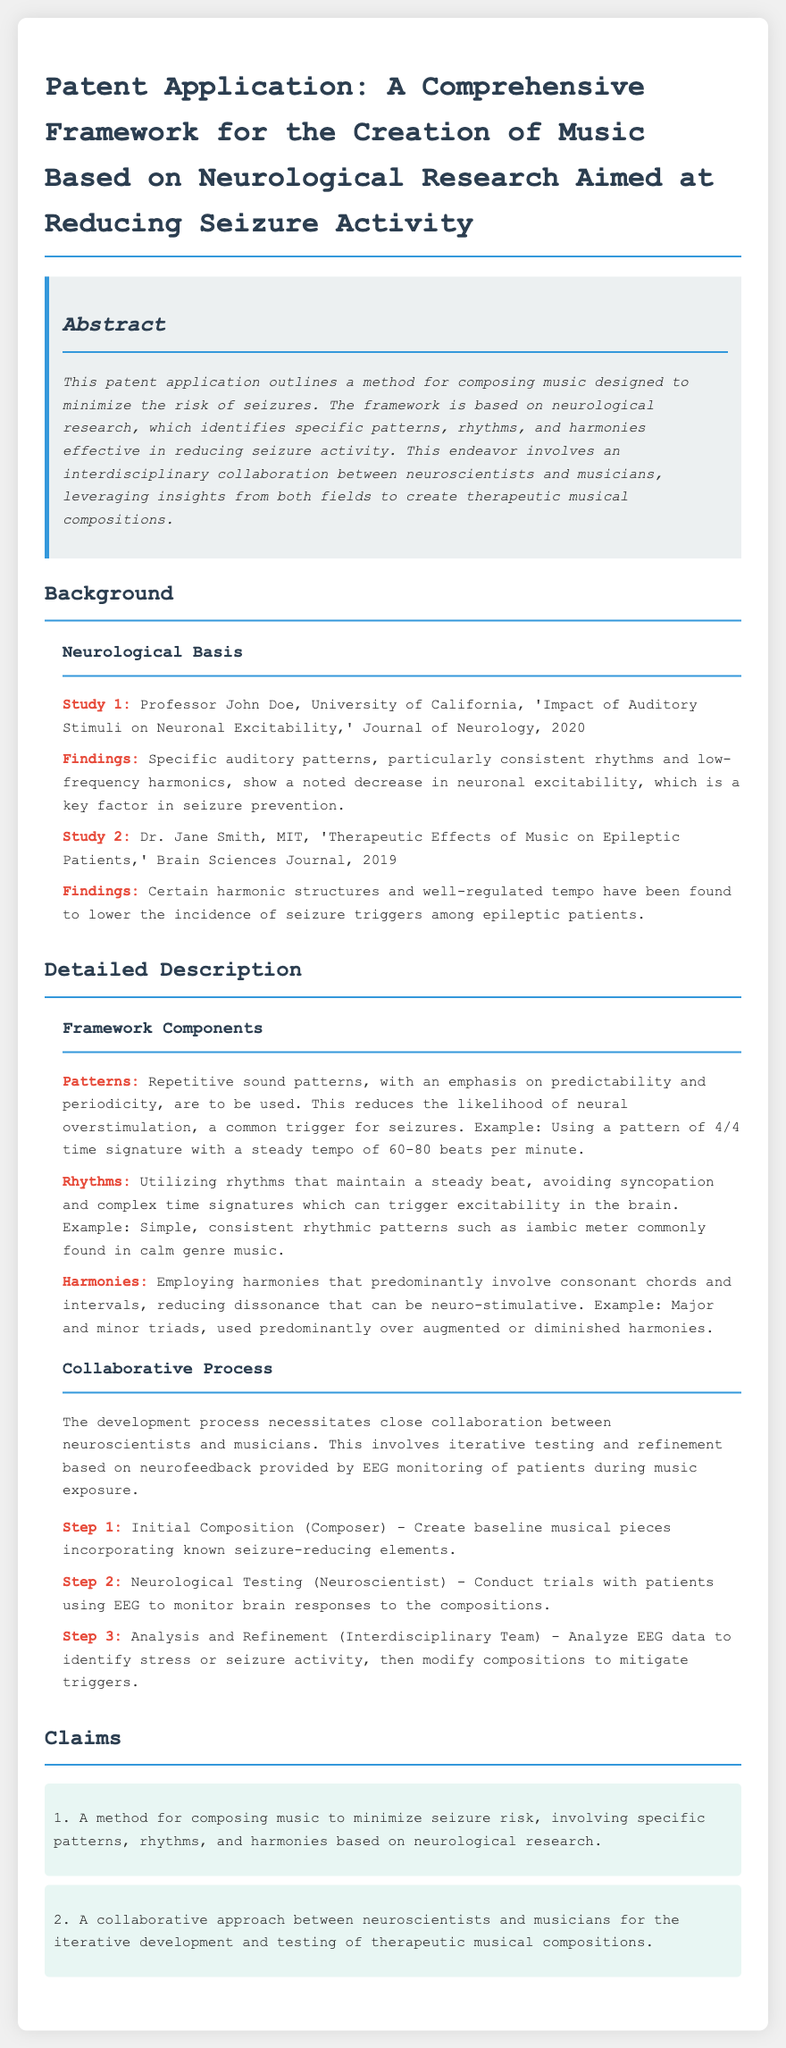What is the title of the patent application? The title is found at the beginning of the document.
Answer: A Comprehensive Framework for the Creation of Music Based on Neurological Research Aimed at Reducing Seizure Activity Who conducted Study 1? The name of the researcher is mentioned in the 'Neurological Basis' section.
Answer: Professor John Doe What rhythmic pattern is suggested to reduce seizure triggers? This information is provided in the 'Framework Components' subsection regarding patterns.
Answer: 4/4 time signature What is the tempo range recommended for music composition? This information can be found in the details of the framework components.
Answer: 60-80 beats per minute What type of chords should be used predominantly in compositions? The answer is located in the 'Harmonies' subsection.
Answer: Consonant chords How many steps are in the collaborative process? The total number of steps is outlined in the 'Collaborative Process' section.
Answer: Three steps Which journal published the findings of Dr. Jane Smith? The journal is listed in the citation for Study 2.
Answer: Brain Sciences Journal What is the first step in the collaborative process? The information is described in the list under the 'Collaborative Process' subsection.
Answer: Initial Composition (Composer) What does EEG stand for? The abbreviation is found in the context of the neurological testing step.
Answer: Electroencephalogram 